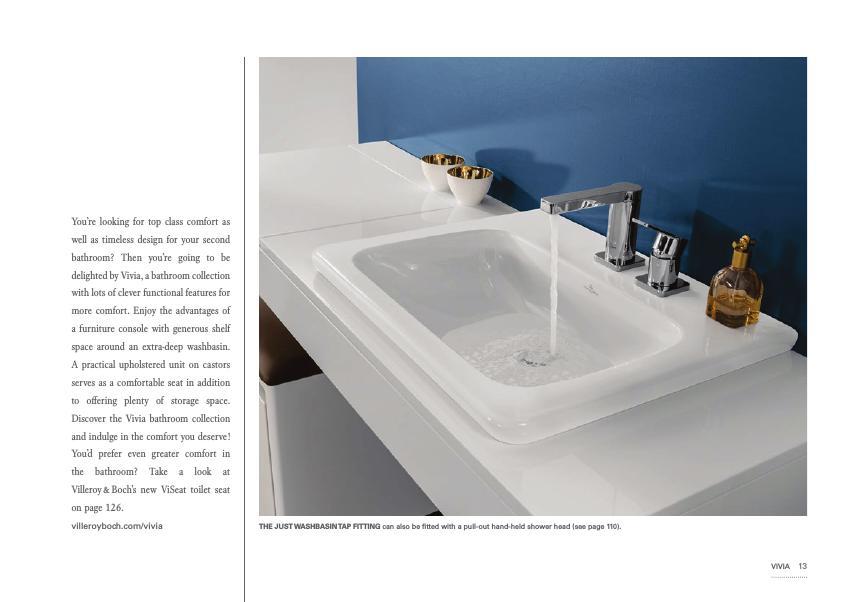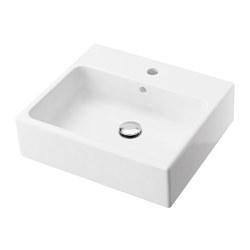The first image is the image on the left, the second image is the image on the right. Given the left and right images, does the statement "One sink has a white rectangular recessed bowl and no faucet or spout mounted to it." hold true? Answer yes or no. Yes. 